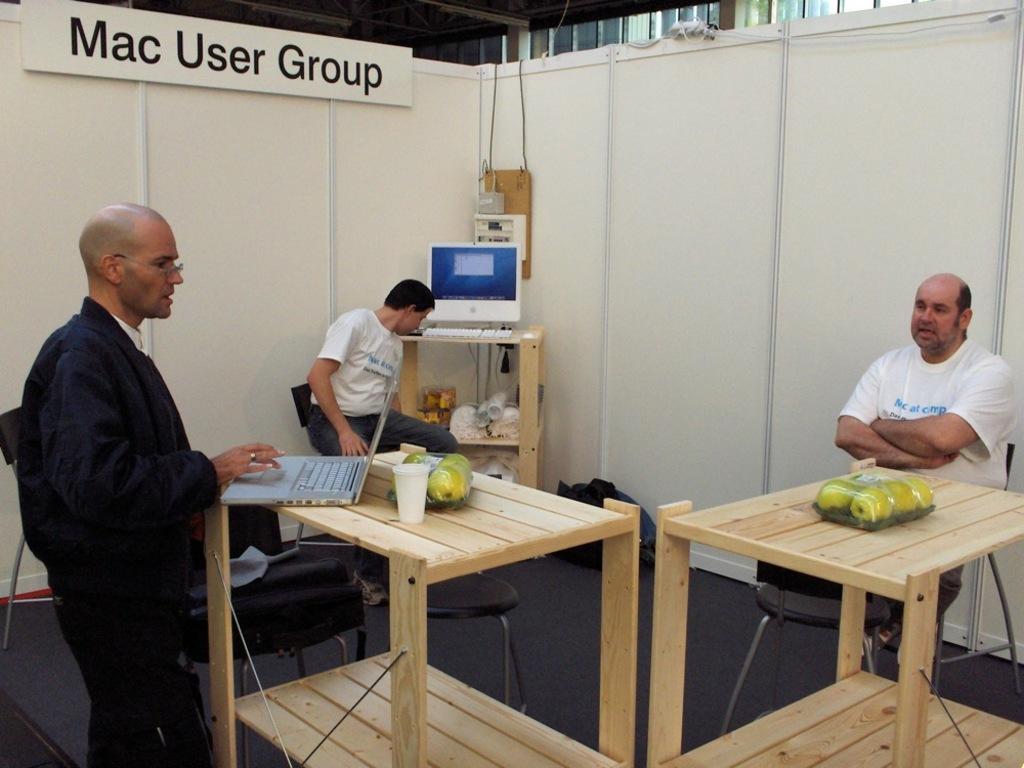Describe this image in one or two sentences. In this image I can see three man where two are sitting on chairs and one is standing. I can see he is wearing a specs. On these tables I can see fruits, a laptop and a glass. In the background I can see a monitor and a keyboard. 